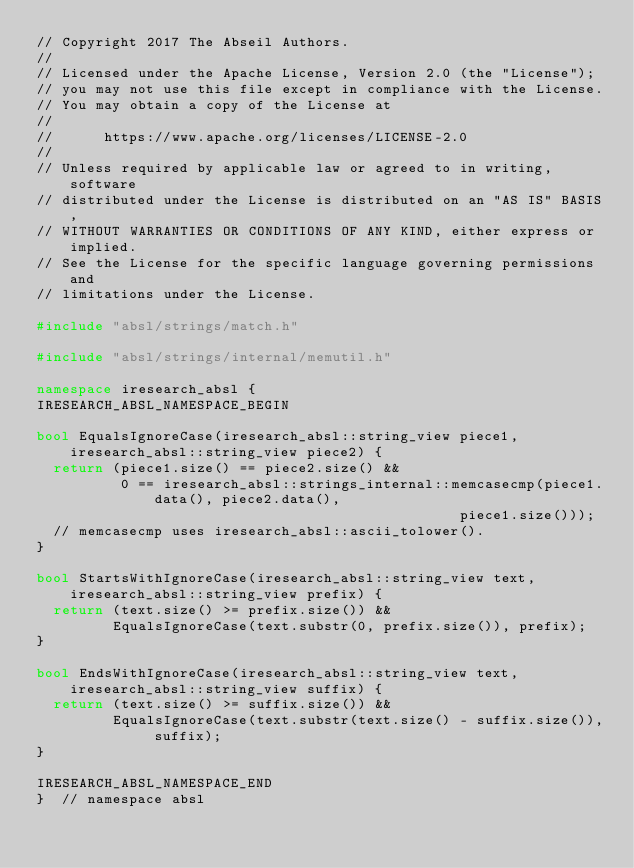<code> <loc_0><loc_0><loc_500><loc_500><_C++_>// Copyright 2017 The Abseil Authors.
//
// Licensed under the Apache License, Version 2.0 (the "License");
// you may not use this file except in compliance with the License.
// You may obtain a copy of the License at
//
//      https://www.apache.org/licenses/LICENSE-2.0
//
// Unless required by applicable law or agreed to in writing, software
// distributed under the License is distributed on an "AS IS" BASIS,
// WITHOUT WARRANTIES OR CONDITIONS OF ANY KIND, either express or implied.
// See the License for the specific language governing permissions and
// limitations under the License.

#include "absl/strings/match.h"

#include "absl/strings/internal/memutil.h"

namespace iresearch_absl {
IRESEARCH_ABSL_NAMESPACE_BEGIN

bool EqualsIgnoreCase(iresearch_absl::string_view piece1, iresearch_absl::string_view piece2) {
  return (piece1.size() == piece2.size() &&
          0 == iresearch_absl::strings_internal::memcasecmp(piece1.data(), piece2.data(),
                                                  piece1.size()));
  // memcasecmp uses iresearch_absl::ascii_tolower().
}

bool StartsWithIgnoreCase(iresearch_absl::string_view text, iresearch_absl::string_view prefix) {
  return (text.size() >= prefix.size()) &&
         EqualsIgnoreCase(text.substr(0, prefix.size()), prefix);
}

bool EndsWithIgnoreCase(iresearch_absl::string_view text, iresearch_absl::string_view suffix) {
  return (text.size() >= suffix.size()) &&
         EqualsIgnoreCase(text.substr(text.size() - suffix.size()), suffix);
}

IRESEARCH_ABSL_NAMESPACE_END
}  // namespace absl
</code> 